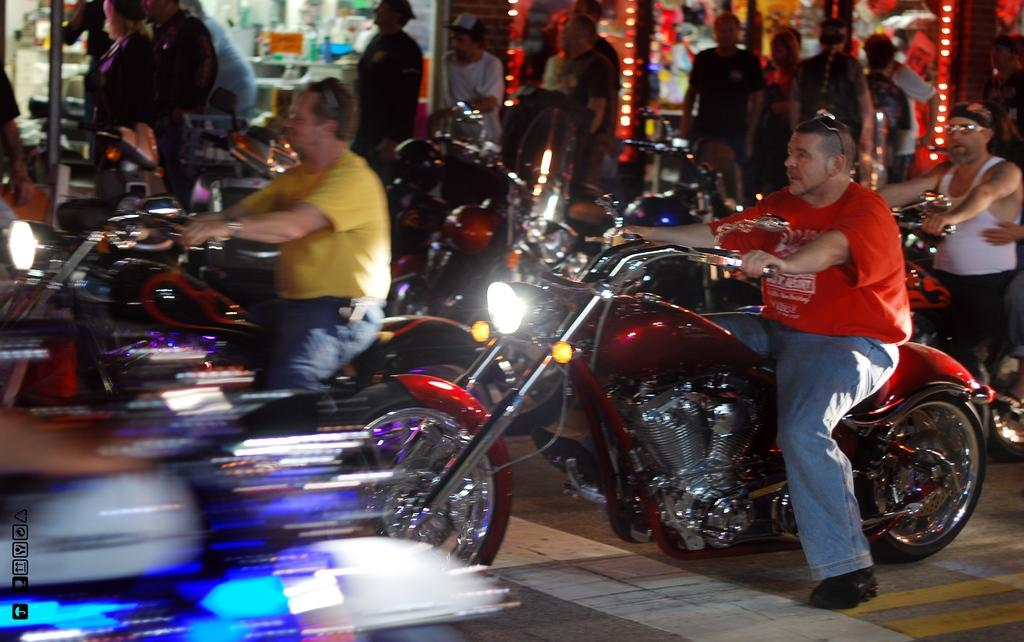What is the main subject of the image? The main subject of the image is a motorbike. Where is the motorbike located? The motorbike is on the road. Are there any other people or objects in the image? Yes, there is a group of people standing in the image. What type of brush is being used to paint the lettuce in the image? There is no brush or lettuce present in the image; it features a motorbike on the road and a group of people standing nearby. 